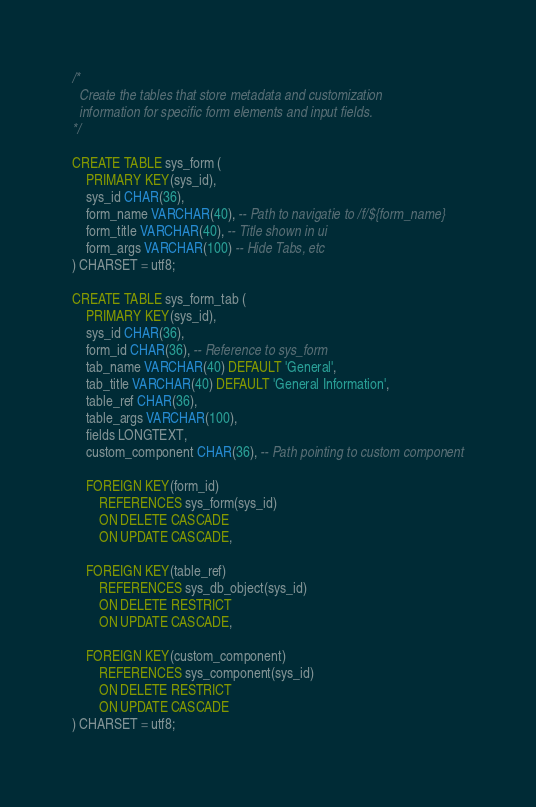Convert code to text. <code><loc_0><loc_0><loc_500><loc_500><_SQL_>/*
  Create the tables that store metadata and customization
  information for specific form elements and input fields.
*/

CREATE TABLE sys_form (
    PRIMARY KEY(sys_id),
    sys_id CHAR(36),
    form_name VARCHAR(40), -- Path to navigatie to /f/${form_name}
    form_title VARCHAR(40), -- Title shown in ui
    form_args VARCHAR(100) -- Hide Tabs, etc
) CHARSET = utf8;

CREATE TABLE sys_form_tab (
    PRIMARY KEY(sys_id),
    sys_id CHAR(36),
    form_id CHAR(36), -- Reference to sys_form
    tab_name VARCHAR(40) DEFAULT 'General',
    tab_title VARCHAR(40) DEFAULT 'General Information',
    table_ref CHAR(36),
    table_args VARCHAR(100),
    fields LONGTEXT,
    custom_component CHAR(36), -- Path pointing to custom component

    FOREIGN KEY(form_id)
        REFERENCES sys_form(sys_id)
        ON DELETE CASCADE
        ON UPDATE CASCADE,

    FOREIGN KEY(table_ref)
        REFERENCES sys_db_object(sys_id)
        ON DELETE RESTRICT
        ON UPDATE CASCADE,

    FOREIGN KEY(custom_component)
        REFERENCES sys_component(sys_id)
        ON DELETE RESTRICT
        ON UPDATE CASCADE
) CHARSET = utf8;</code> 